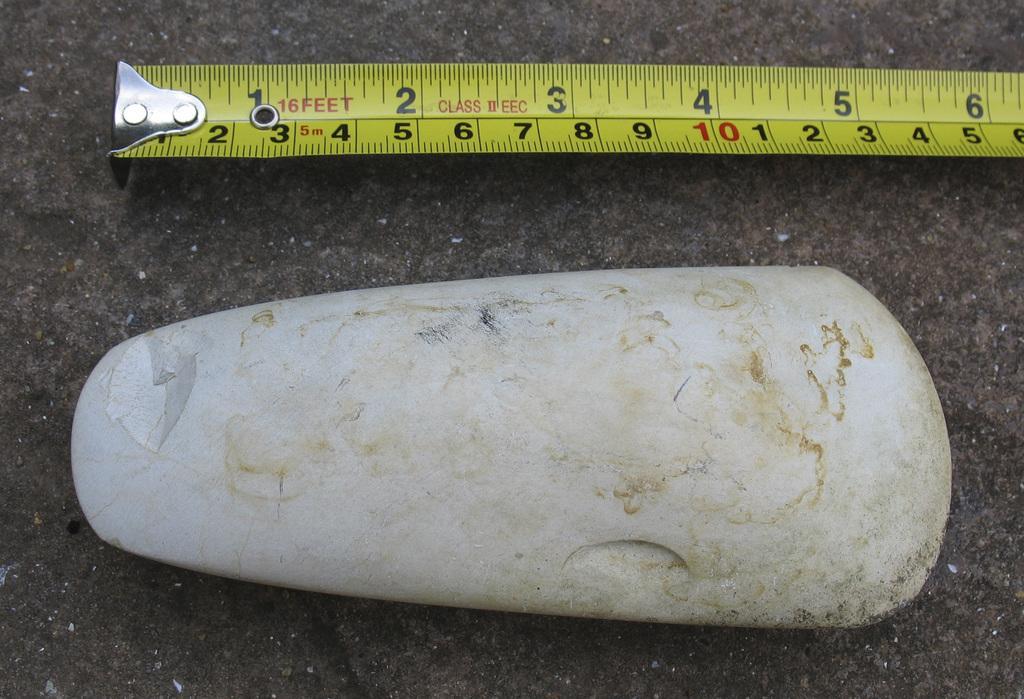Could you give a brief overview of what you see in this image? Beside this rock we can see a measuring tape. 